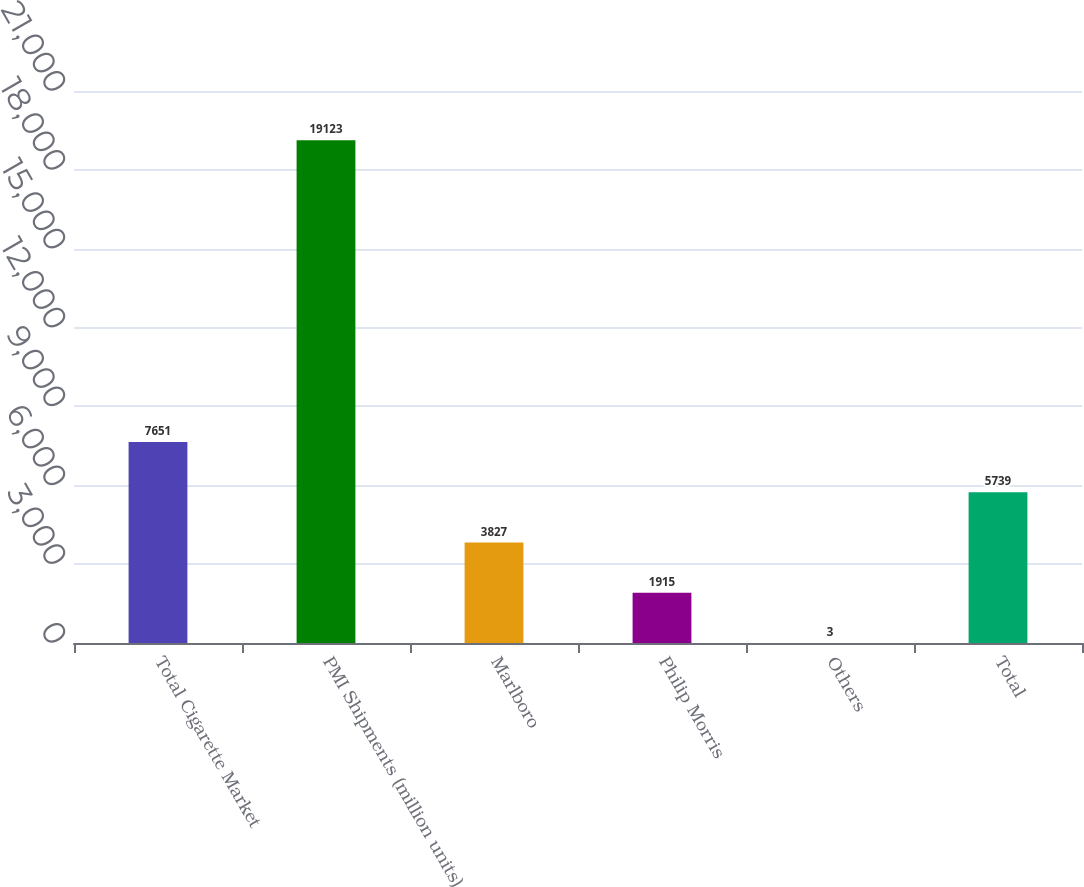<chart> <loc_0><loc_0><loc_500><loc_500><bar_chart><fcel>Total Cigarette Market<fcel>PMI Shipments (million units)<fcel>Marlboro<fcel>Philip Morris<fcel>Others<fcel>Total<nl><fcel>7651<fcel>19123<fcel>3827<fcel>1915<fcel>3<fcel>5739<nl></chart> 